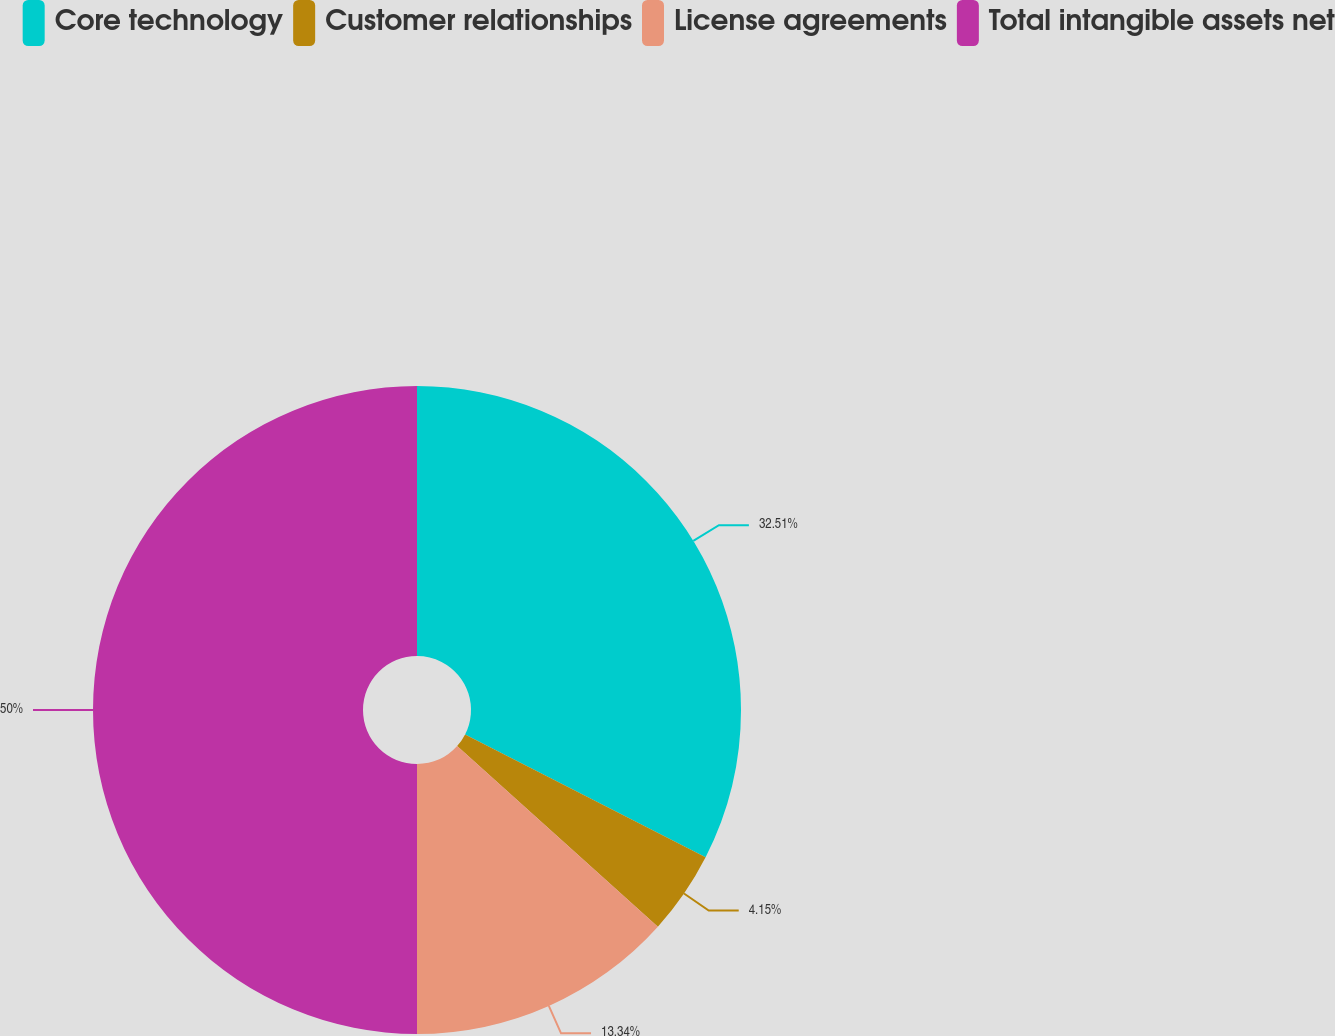Convert chart. <chart><loc_0><loc_0><loc_500><loc_500><pie_chart><fcel>Core technology<fcel>Customer relationships<fcel>License agreements<fcel>Total intangible assets net<nl><fcel>32.51%<fcel>4.15%<fcel>13.34%<fcel>50.0%<nl></chart> 